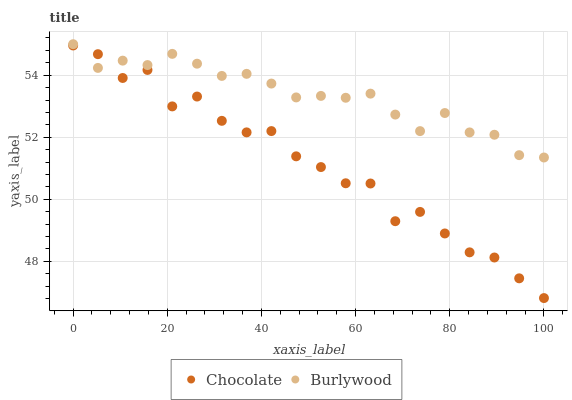Does Chocolate have the minimum area under the curve?
Answer yes or no. Yes. Does Burlywood have the maximum area under the curve?
Answer yes or no. Yes. Does Chocolate have the maximum area under the curve?
Answer yes or no. No. Is Burlywood the smoothest?
Answer yes or no. Yes. Is Chocolate the roughest?
Answer yes or no. Yes. Is Chocolate the smoothest?
Answer yes or no. No. Does Chocolate have the lowest value?
Answer yes or no. Yes. Does Burlywood have the highest value?
Answer yes or no. Yes. Does Chocolate have the highest value?
Answer yes or no. No. Does Burlywood intersect Chocolate?
Answer yes or no. Yes. Is Burlywood less than Chocolate?
Answer yes or no. No. Is Burlywood greater than Chocolate?
Answer yes or no. No. 